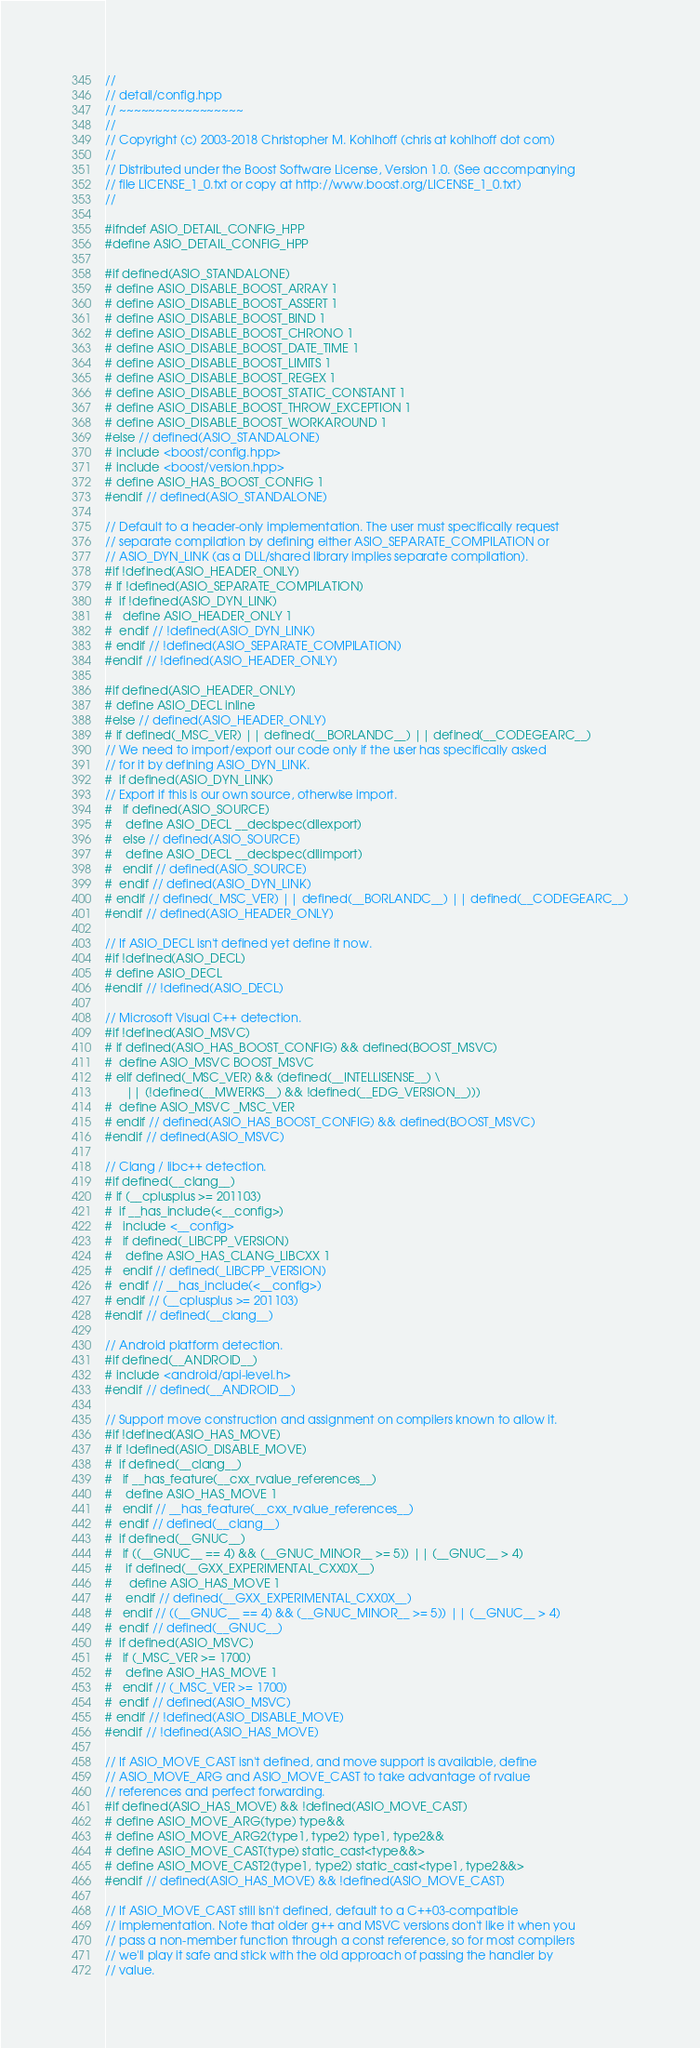Convert code to text. <code><loc_0><loc_0><loc_500><loc_500><_C++_>//
// detail/config.hpp
// ~~~~~~~~~~~~~~~~~
//
// Copyright (c) 2003-2018 Christopher M. Kohlhoff (chris at kohlhoff dot com)
//
// Distributed under the Boost Software License, Version 1.0. (See accompanying
// file LICENSE_1_0.txt or copy at http://www.boost.org/LICENSE_1_0.txt)
//

#ifndef ASIO_DETAIL_CONFIG_HPP
#define ASIO_DETAIL_CONFIG_HPP

#if defined(ASIO_STANDALONE)
# define ASIO_DISABLE_BOOST_ARRAY 1
# define ASIO_DISABLE_BOOST_ASSERT 1
# define ASIO_DISABLE_BOOST_BIND 1
# define ASIO_DISABLE_BOOST_CHRONO 1
# define ASIO_DISABLE_BOOST_DATE_TIME 1
# define ASIO_DISABLE_BOOST_LIMITS 1
# define ASIO_DISABLE_BOOST_REGEX 1
# define ASIO_DISABLE_BOOST_STATIC_CONSTANT 1
# define ASIO_DISABLE_BOOST_THROW_EXCEPTION 1
# define ASIO_DISABLE_BOOST_WORKAROUND 1
#else // defined(ASIO_STANDALONE)
# include <boost/config.hpp>
# include <boost/version.hpp>
# define ASIO_HAS_BOOST_CONFIG 1
#endif // defined(ASIO_STANDALONE)

// Default to a header-only implementation. The user must specifically request
// separate compilation by defining either ASIO_SEPARATE_COMPILATION or
// ASIO_DYN_LINK (as a DLL/shared library implies separate compilation).
#if !defined(ASIO_HEADER_ONLY)
# if !defined(ASIO_SEPARATE_COMPILATION)
#  if !defined(ASIO_DYN_LINK)
#   define ASIO_HEADER_ONLY 1
#  endif // !defined(ASIO_DYN_LINK)
# endif // !defined(ASIO_SEPARATE_COMPILATION)
#endif // !defined(ASIO_HEADER_ONLY)

#if defined(ASIO_HEADER_ONLY)
# define ASIO_DECL inline
#else // defined(ASIO_HEADER_ONLY)
# if defined(_MSC_VER) || defined(__BORLANDC__) || defined(__CODEGEARC__)
// We need to import/export our code only if the user has specifically asked
// for it by defining ASIO_DYN_LINK.
#  if defined(ASIO_DYN_LINK)
// Export if this is our own source, otherwise import.
#   if defined(ASIO_SOURCE)
#    define ASIO_DECL __declspec(dllexport)
#   else // defined(ASIO_SOURCE)
#    define ASIO_DECL __declspec(dllimport)
#   endif // defined(ASIO_SOURCE)
#  endif // defined(ASIO_DYN_LINK)
# endif // defined(_MSC_VER) || defined(__BORLANDC__) || defined(__CODEGEARC__)
#endif // defined(ASIO_HEADER_ONLY)

// If ASIO_DECL isn't defined yet define it now.
#if !defined(ASIO_DECL)
# define ASIO_DECL
#endif // !defined(ASIO_DECL)

// Microsoft Visual C++ detection.
#if !defined(ASIO_MSVC)
# if defined(ASIO_HAS_BOOST_CONFIG) && defined(BOOST_MSVC)
#  define ASIO_MSVC BOOST_MSVC
# elif defined(_MSC_VER) && (defined(__INTELLISENSE__) \
      || (!defined(__MWERKS__) && !defined(__EDG_VERSION__)))
#  define ASIO_MSVC _MSC_VER
# endif // defined(ASIO_HAS_BOOST_CONFIG) && defined(BOOST_MSVC)
#endif // defined(ASIO_MSVC)

// Clang / libc++ detection.
#if defined(__clang__)
# if (__cplusplus >= 201103)
#  if __has_include(<__config>)
#   include <__config>
#   if defined(_LIBCPP_VERSION)
#    define ASIO_HAS_CLANG_LIBCXX 1
#   endif // defined(_LIBCPP_VERSION)
#  endif // __has_include(<__config>)
# endif // (__cplusplus >= 201103)
#endif // defined(__clang__)

// Android platform detection.
#if defined(__ANDROID__)
# include <android/api-level.h>
#endif // defined(__ANDROID__)

// Support move construction and assignment on compilers known to allow it.
#if !defined(ASIO_HAS_MOVE)
# if !defined(ASIO_DISABLE_MOVE)
#  if defined(__clang__)
#   if __has_feature(__cxx_rvalue_references__)
#    define ASIO_HAS_MOVE 1
#   endif // __has_feature(__cxx_rvalue_references__)
#  endif // defined(__clang__)
#  if defined(__GNUC__)
#   if ((__GNUC__ == 4) && (__GNUC_MINOR__ >= 5)) || (__GNUC__ > 4)
#    if defined(__GXX_EXPERIMENTAL_CXX0X__)
#     define ASIO_HAS_MOVE 1
#    endif // defined(__GXX_EXPERIMENTAL_CXX0X__)
#   endif // ((__GNUC__ == 4) && (__GNUC_MINOR__ >= 5)) || (__GNUC__ > 4)
#  endif // defined(__GNUC__)
#  if defined(ASIO_MSVC)
#   if (_MSC_VER >= 1700)
#    define ASIO_HAS_MOVE 1
#   endif // (_MSC_VER >= 1700)
#  endif // defined(ASIO_MSVC)
# endif // !defined(ASIO_DISABLE_MOVE)
#endif // !defined(ASIO_HAS_MOVE)

// If ASIO_MOVE_CAST isn't defined, and move support is available, define
// ASIO_MOVE_ARG and ASIO_MOVE_CAST to take advantage of rvalue
// references and perfect forwarding.
#if defined(ASIO_HAS_MOVE) && !defined(ASIO_MOVE_CAST)
# define ASIO_MOVE_ARG(type) type&&
# define ASIO_MOVE_ARG2(type1, type2) type1, type2&&
# define ASIO_MOVE_CAST(type) static_cast<type&&>
# define ASIO_MOVE_CAST2(type1, type2) static_cast<type1, type2&&>
#endif // defined(ASIO_HAS_MOVE) && !defined(ASIO_MOVE_CAST)

// If ASIO_MOVE_CAST still isn't defined, default to a C++03-compatible
// implementation. Note that older g++ and MSVC versions don't like it when you
// pass a non-member function through a const reference, so for most compilers
// we'll play it safe and stick with the old approach of passing the handler by
// value.</code> 